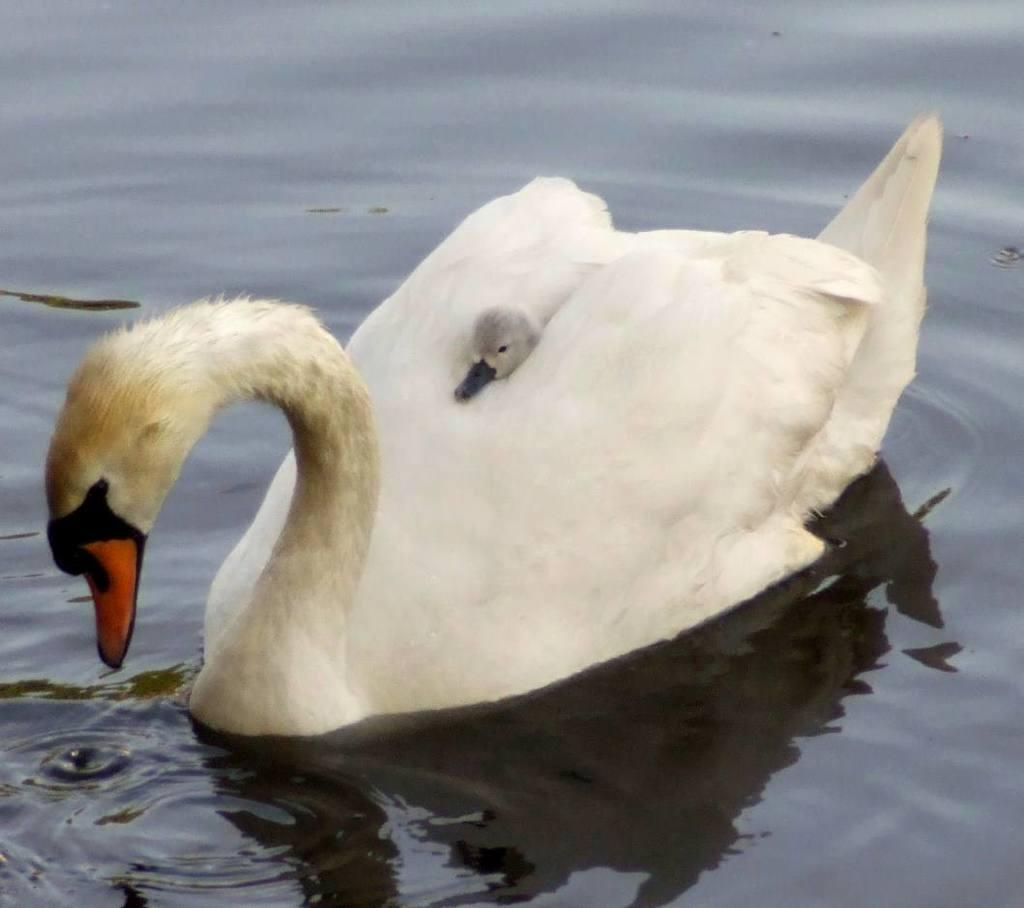What type of animal is in the image? There is a bird in the image. Can you describe the bird's appearance? The bird has a combination of white, cream, brown, black, and orange colors. Where is the bird located in the image? The bird is on the surface of the water. Are there any other birds in the image? Yes, there is a small bird in the image. What color is the small bird? The small bird is black in color. Does the bird have an arm in the image? No, birds do not have arms; they have wings. The bird in the image has wings, not arms. 